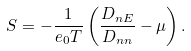<formula> <loc_0><loc_0><loc_500><loc_500>S = - \frac { 1 } { e _ { 0 } T } \left ( \frac { D _ { n E } } { D _ { n n } } - \mu \right ) .</formula> 